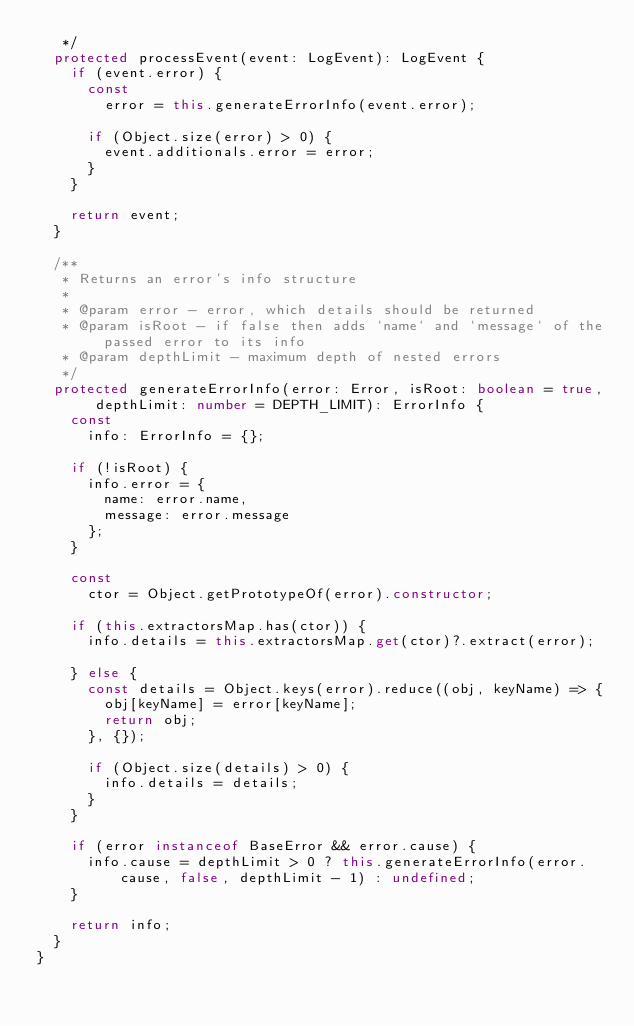Convert code to text. <code><loc_0><loc_0><loc_500><loc_500><_TypeScript_>	 */
	protected processEvent(event: LogEvent): LogEvent {
		if (event.error) {
			const
				error = this.generateErrorInfo(event.error);

			if (Object.size(error) > 0) {
				event.additionals.error = error;
			}
		}

		return event;
	}

	/**
	 * Returns an error's info structure
	 *
	 * @param error - error, which details should be returned
	 * @param isRoot - if false then adds `name` and `message` of the passed error to its info
	 * @param depthLimit - maximum depth of nested errors
	 */
	protected generateErrorInfo(error: Error, isRoot: boolean = true, depthLimit: number = DEPTH_LIMIT): ErrorInfo {
		const
			info: ErrorInfo = {};

		if (!isRoot) {
			info.error = {
				name: error.name,
				message: error.message
			};
		}

		const
			ctor = Object.getPrototypeOf(error).constructor;

		if (this.extractorsMap.has(ctor)) {
			info.details = this.extractorsMap.get(ctor)?.extract(error);

		} else {
			const details = Object.keys(error).reduce((obj, keyName) => {
				obj[keyName] = error[keyName];
				return obj;
			}, {});

			if (Object.size(details) > 0) {
				info.details = details;
			}
		}

		if (error instanceof BaseError && error.cause) {
			info.cause = depthLimit > 0 ? this.generateErrorInfo(error.cause, false, depthLimit - 1) : undefined;
		}

		return info;
	}
}
</code> 